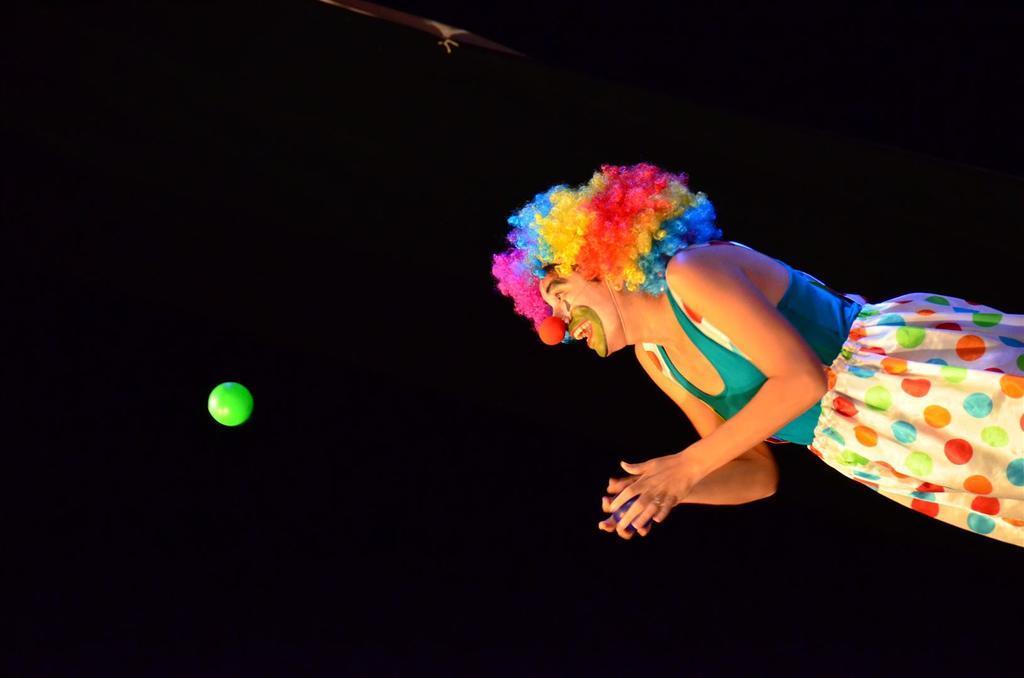What is the main subject of the image? There is a person in the image. What is the person holding in their hand? The person is holding a ball in their hand. Can you describe the other object in the image? There is another ball in the air in front of the person. What type of book is the person reading in the image? There is no book present in the image; the person is holding a ball in their hand and there is another ball in the air in front of them. 